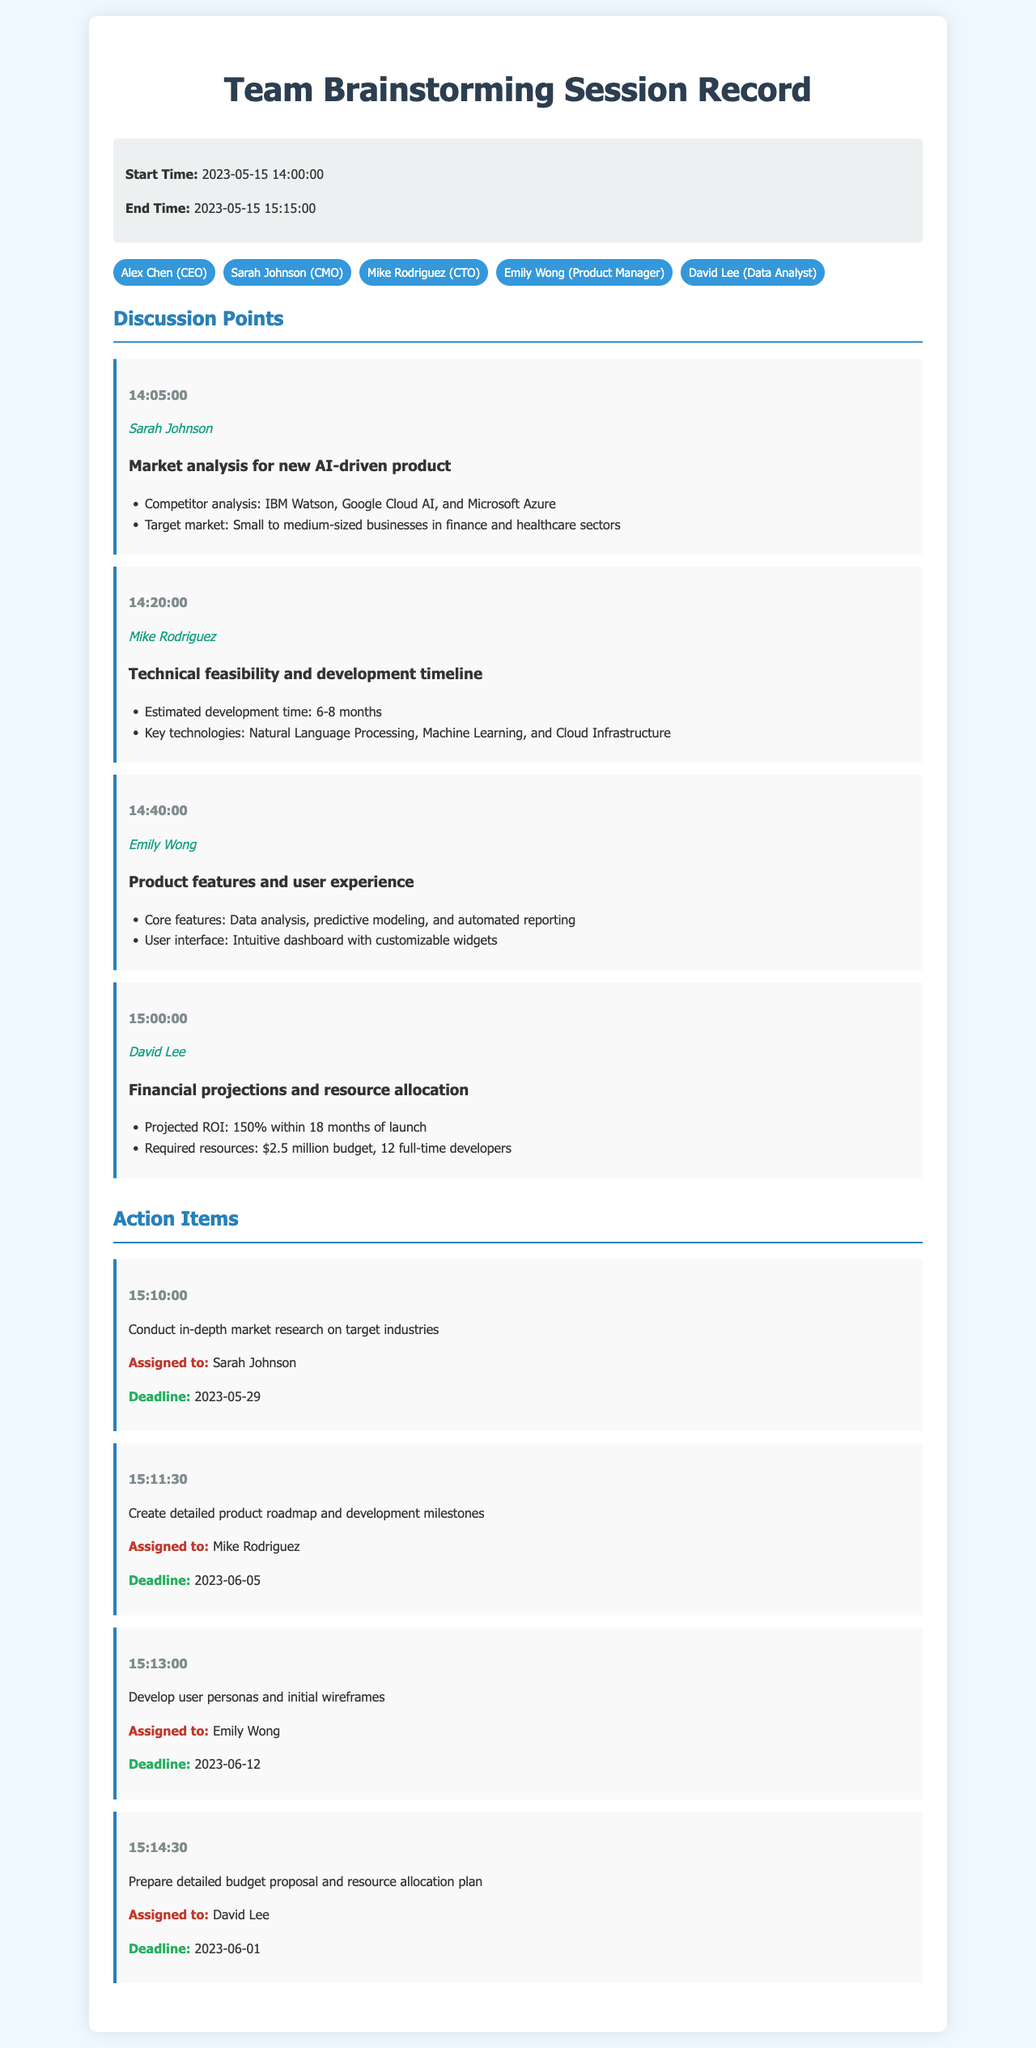what is the start time of the session? The start time is explicitly stated in the session info section of the document.
Answer: 2023-05-15 14:00:00 who is the speaker for the market analysis discussion? The speaker's name is provided alongside each discussion point.
Answer: Sarah Johnson what are the core features of the product discussed? The core features are listed as part of the product features and user experience section.
Answer: Data analysis, predictive modeling, and automated reporting how many months is the estimated development time? The estimated development time is mentioned in the technical feasibility discussion.
Answer: 6-8 months which action item is assigned to Mike Rodriguez? The action items are detailed with assigned personnel next to each item.
Answer: Create detailed product roadmap and development milestones what is the projected ROI mentioned for the product? The projected ROI is provided in the financial projections discussion.
Answer: 150% what is the deadline for Sarah Johnson's action item? The deadline is specified next to each action item in the document.
Answer: 2023-05-29 what technologies are key for product development? Key technologies are listed in the technical feasibility point of the discussion.
Answer: Natural Language Processing, Machine Learning, and Cloud Infrastructure how many participants are in the session? The number of participants is given in the participants' list section.
Answer: 5 